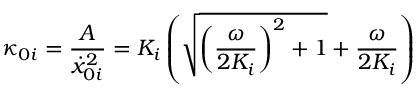<formula> <loc_0><loc_0><loc_500><loc_500>\kappa _ { 0 i } = \frac { A } { \dot { x } _ { 0 i } ^ { 2 } } = K _ { i } \left ( \sqrt { { \left ( \frac { \omega } { 2 K _ { i } } \right ) } ^ { 2 } + 1 } + \frac { \omega } { 2 K _ { i } } \right )</formula> 